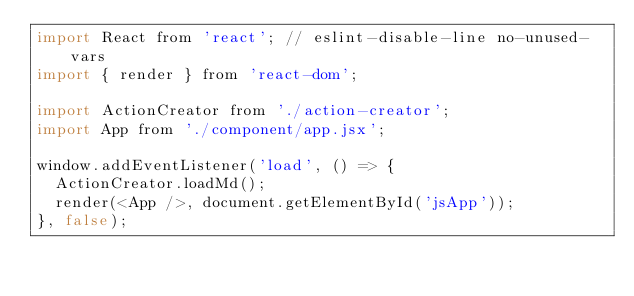Convert code to text. <code><loc_0><loc_0><loc_500><loc_500><_JavaScript_>import React from 'react'; // eslint-disable-line no-unused-vars
import { render } from 'react-dom';

import ActionCreator from './action-creator';
import App from './component/app.jsx';

window.addEventListener('load', () => {
  ActionCreator.loadMd();
  render(<App />, document.getElementById('jsApp'));
}, false);
</code> 